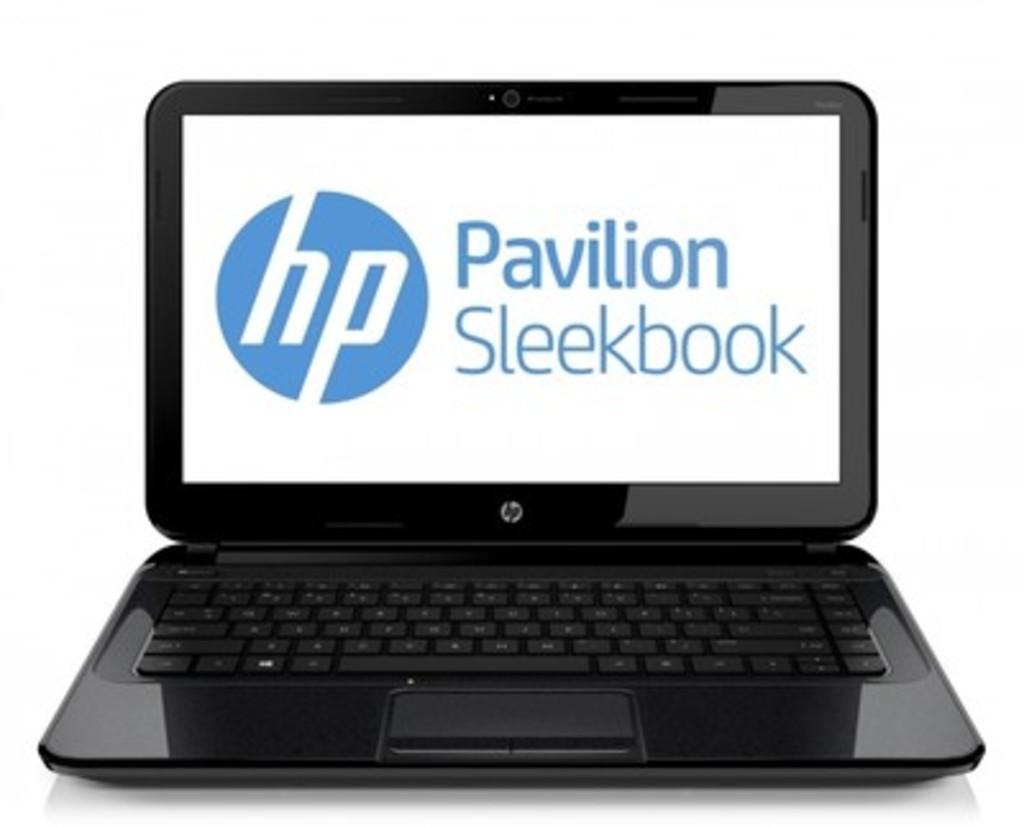What is the main object in the center of the image? There is a laptop in the center of the image. What are the laptop's features? The laptop has keys. What can be seen on the laptop screen? There is text visible on the laptop screen. Can you see any visible veins on the laptop screen? There are no visible veins on the laptop screen; it displays text. What type of cork is used to secure the laptop to the table? There is no cork present in the image, and the laptop is not secured to the table. 